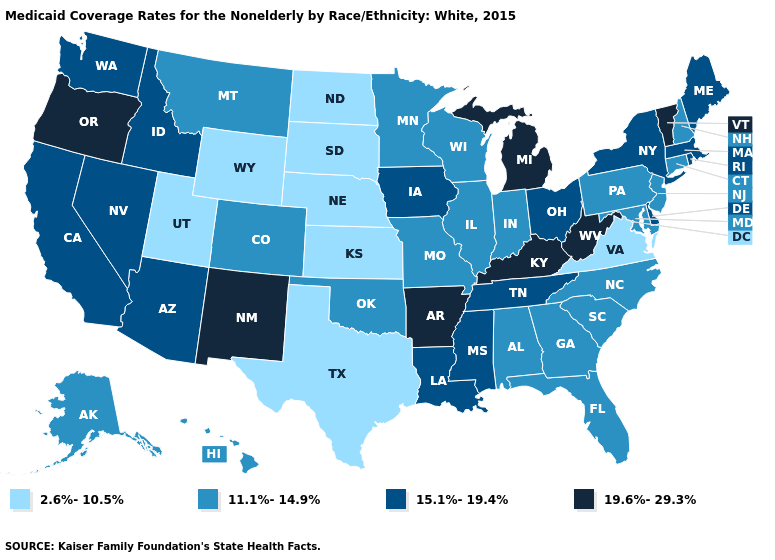What is the value of Michigan?
Be succinct. 19.6%-29.3%. Which states have the lowest value in the South?
Give a very brief answer. Texas, Virginia. What is the value of Michigan?
Quick response, please. 19.6%-29.3%. How many symbols are there in the legend?
Give a very brief answer. 4. Name the states that have a value in the range 11.1%-14.9%?
Keep it brief. Alabama, Alaska, Colorado, Connecticut, Florida, Georgia, Hawaii, Illinois, Indiana, Maryland, Minnesota, Missouri, Montana, New Hampshire, New Jersey, North Carolina, Oklahoma, Pennsylvania, South Carolina, Wisconsin. What is the value of New Hampshire?
Give a very brief answer. 11.1%-14.9%. Which states hav the highest value in the South?
Short answer required. Arkansas, Kentucky, West Virginia. Does the map have missing data?
Keep it brief. No. Among the states that border New Hampshire , which have the highest value?
Write a very short answer. Vermont. What is the lowest value in the Northeast?
Quick response, please. 11.1%-14.9%. Name the states that have a value in the range 15.1%-19.4%?
Short answer required. Arizona, California, Delaware, Idaho, Iowa, Louisiana, Maine, Massachusetts, Mississippi, Nevada, New York, Ohio, Rhode Island, Tennessee, Washington. How many symbols are there in the legend?
Quick response, please. 4. What is the lowest value in states that border Connecticut?
Answer briefly. 15.1%-19.4%. What is the value of Maine?
Write a very short answer. 15.1%-19.4%. Does Virginia have the lowest value in the South?
Quick response, please. Yes. 